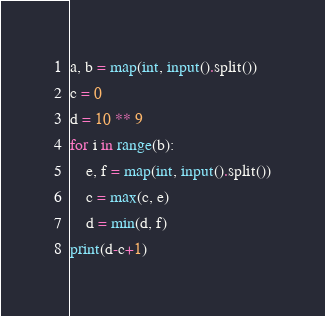Convert code to text. <code><loc_0><loc_0><loc_500><loc_500><_Python_>a, b = map(int, input().split())
c = 0
d = 10 ** 9
for i in range(b):
    e, f = map(int, input().split())
    c = max(c, e)
    d = min(d, f)
print(d-c+1)
</code> 